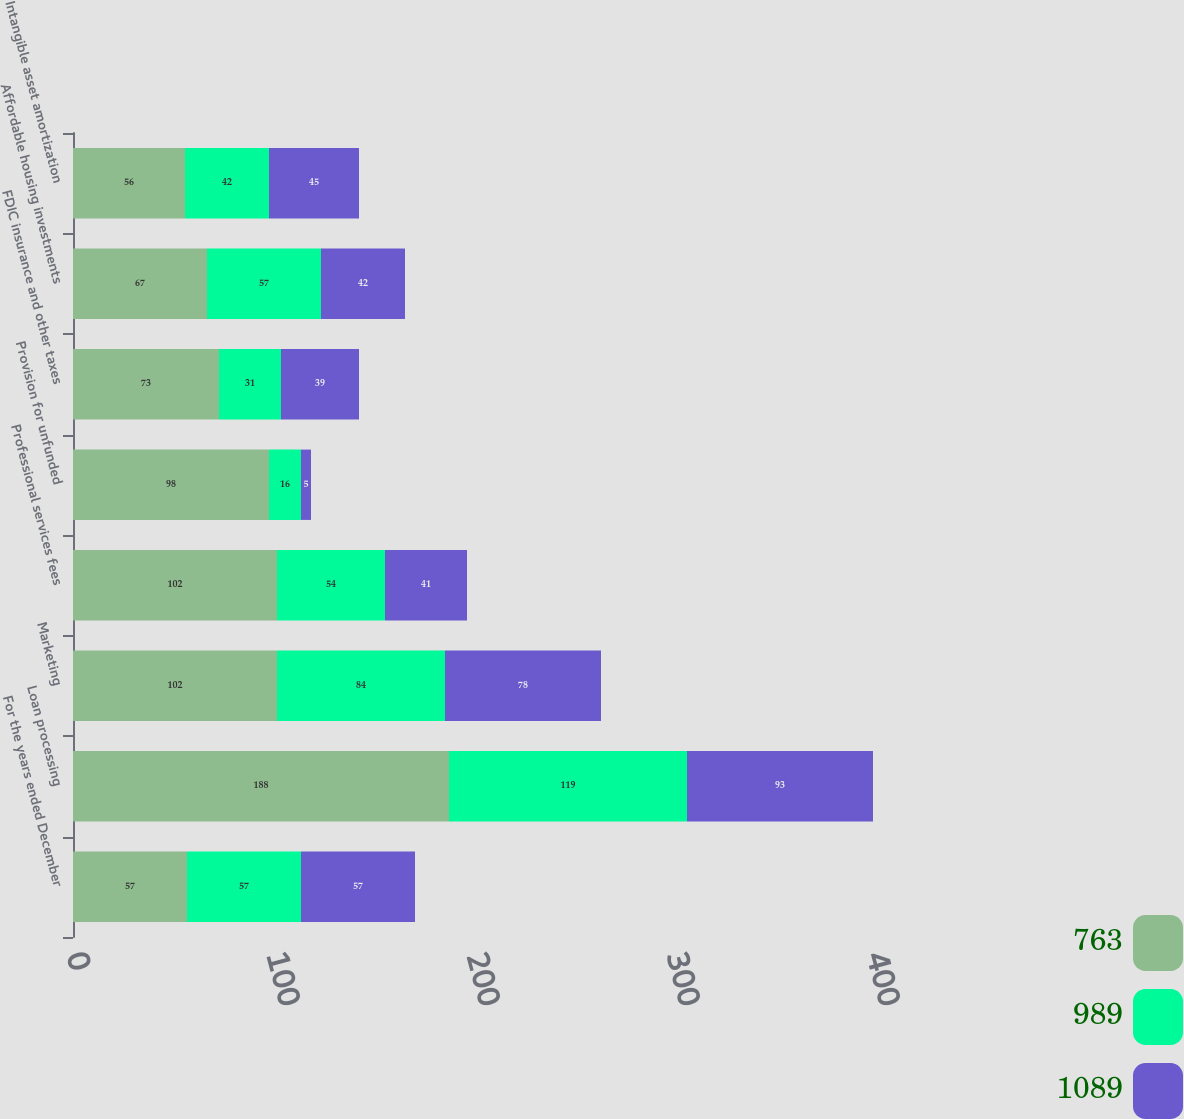Convert chart. <chart><loc_0><loc_0><loc_500><loc_500><stacked_bar_chart><ecel><fcel>For the years ended December<fcel>Loan processing<fcel>Marketing<fcel>Professional services fees<fcel>Provision for unfunded<fcel>FDIC insurance and other taxes<fcel>Affordable housing investments<fcel>Intangible asset amortization<nl><fcel>763<fcel>57<fcel>188<fcel>102<fcel>102<fcel>98<fcel>73<fcel>67<fcel>56<nl><fcel>989<fcel>57<fcel>119<fcel>84<fcel>54<fcel>16<fcel>31<fcel>57<fcel>42<nl><fcel>1089<fcel>57<fcel>93<fcel>78<fcel>41<fcel>5<fcel>39<fcel>42<fcel>45<nl></chart> 